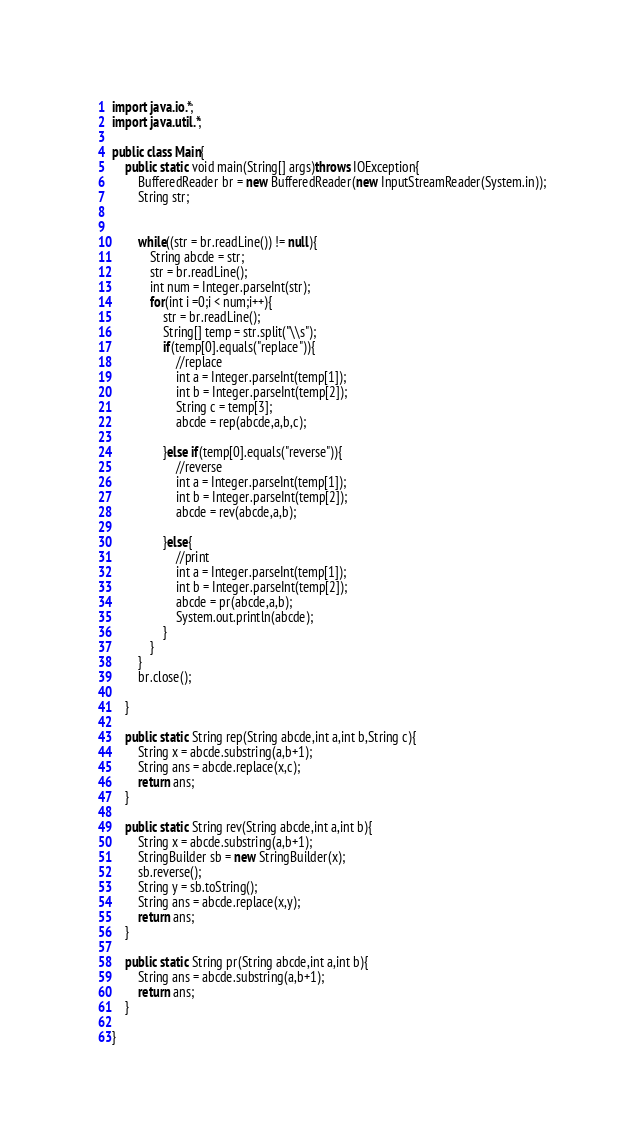<code> <loc_0><loc_0><loc_500><loc_500><_Java_>import java.io.*;
import java.util.*;

public class Main{
    public static void main(String[] args)throws IOException{
        BufferedReader br = new BufferedReader(new InputStreamReader(System.in));
        String str;

         
        while((str = br.readLine()) != null){
            String abcde = str;
            str = br.readLine();
            int num = Integer.parseInt(str);
            for(int i =0;i < num;i++){
                str = br.readLine();
                String[] temp = str.split("\\s");
                if(temp[0].equals("replace")){
                    //replace
                    int a = Integer.parseInt(temp[1]);
                    int b = Integer.parseInt(temp[2]);
                    String c = temp[3];
                    abcde = rep(abcde,a,b,c);

                }else if(temp[0].equals("reverse")){
                    //reverse
                    int a = Integer.parseInt(temp[1]);
                    int b = Integer.parseInt(temp[2]);
                    abcde = rev(abcde,a,b);

                }else{
                    //print
                    int a = Integer.parseInt(temp[1]);
                    int b = Integer.parseInt(temp[2]);                             
                    abcde = pr(abcde,a,b);
                    System.out.println(abcde);
                }
            }
        }
        br.close();
                  
    }

    public static String rep(String abcde,int a,int b,String c){
        String x = abcde.substring(a,b+1);
        String ans = abcde.replace(x,c);
        return ans;
    }

    public static String rev(String abcde,int a,int b){
        String x = abcde.substring(a,b+1);
        StringBuilder sb = new StringBuilder(x);
        sb.reverse();
        String y = sb.toString();
        String ans = abcde.replace(x,y);
        return ans;
    }

    public static String pr(String abcde,int a,int b){
        String ans = abcde.substring(a,b+1);
        return ans;
    }

}</code> 